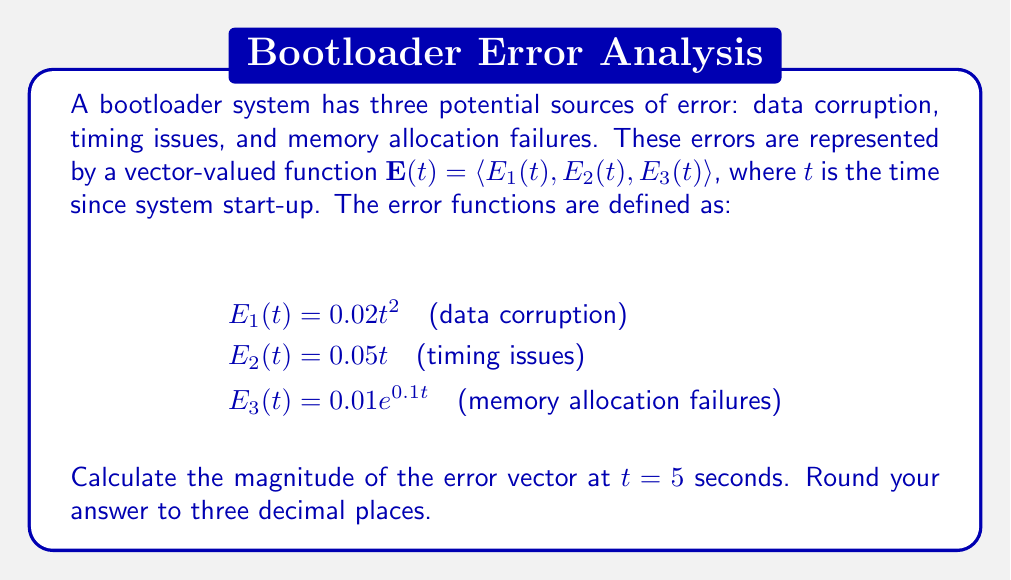Solve this math problem. To solve this problem, we need to follow these steps:

1. Understand the vector-valued error function:
   $\mathbf{E}(t) = \langle E_1(t), E_2(t), E_3(t) \rangle$

2. Calculate each component of the error vector at $t = 5$:

   $E_1(5) = 0.02(5^2) = 0.02 \cdot 25 = 0.5$
   $E_2(5) = 0.05 \cdot 5 = 0.25$
   $E_3(5) = 0.01e^{0.1 \cdot 5} = 0.01e^{0.5} \approx 0.01648$

3. The error vector at $t = 5$ is:
   $\mathbf{E}(5) = \langle 0.5, 0.25, 0.01648 \rangle$

4. To find the magnitude of this vector, we use the formula:
   $\|\mathbf{E}(5)\| = \sqrt{E_1(5)^2 + E_2(5)^2 + E_3(5)^2}$

5. Substitute the values:
   $\|\mathbf{E}(5)\| = \sqrt{0.5^2 + 0.25^2 + 0.01648^2}$

6. Calculate:
   $\|\mathbf{E}(5)\| = \sqrt{0.25 + 0.0625 + 0.000271} = \sqrt{0.312771} \approx 0.559$

7. Round to three decimal places: 0.559
Answer: 0.559 